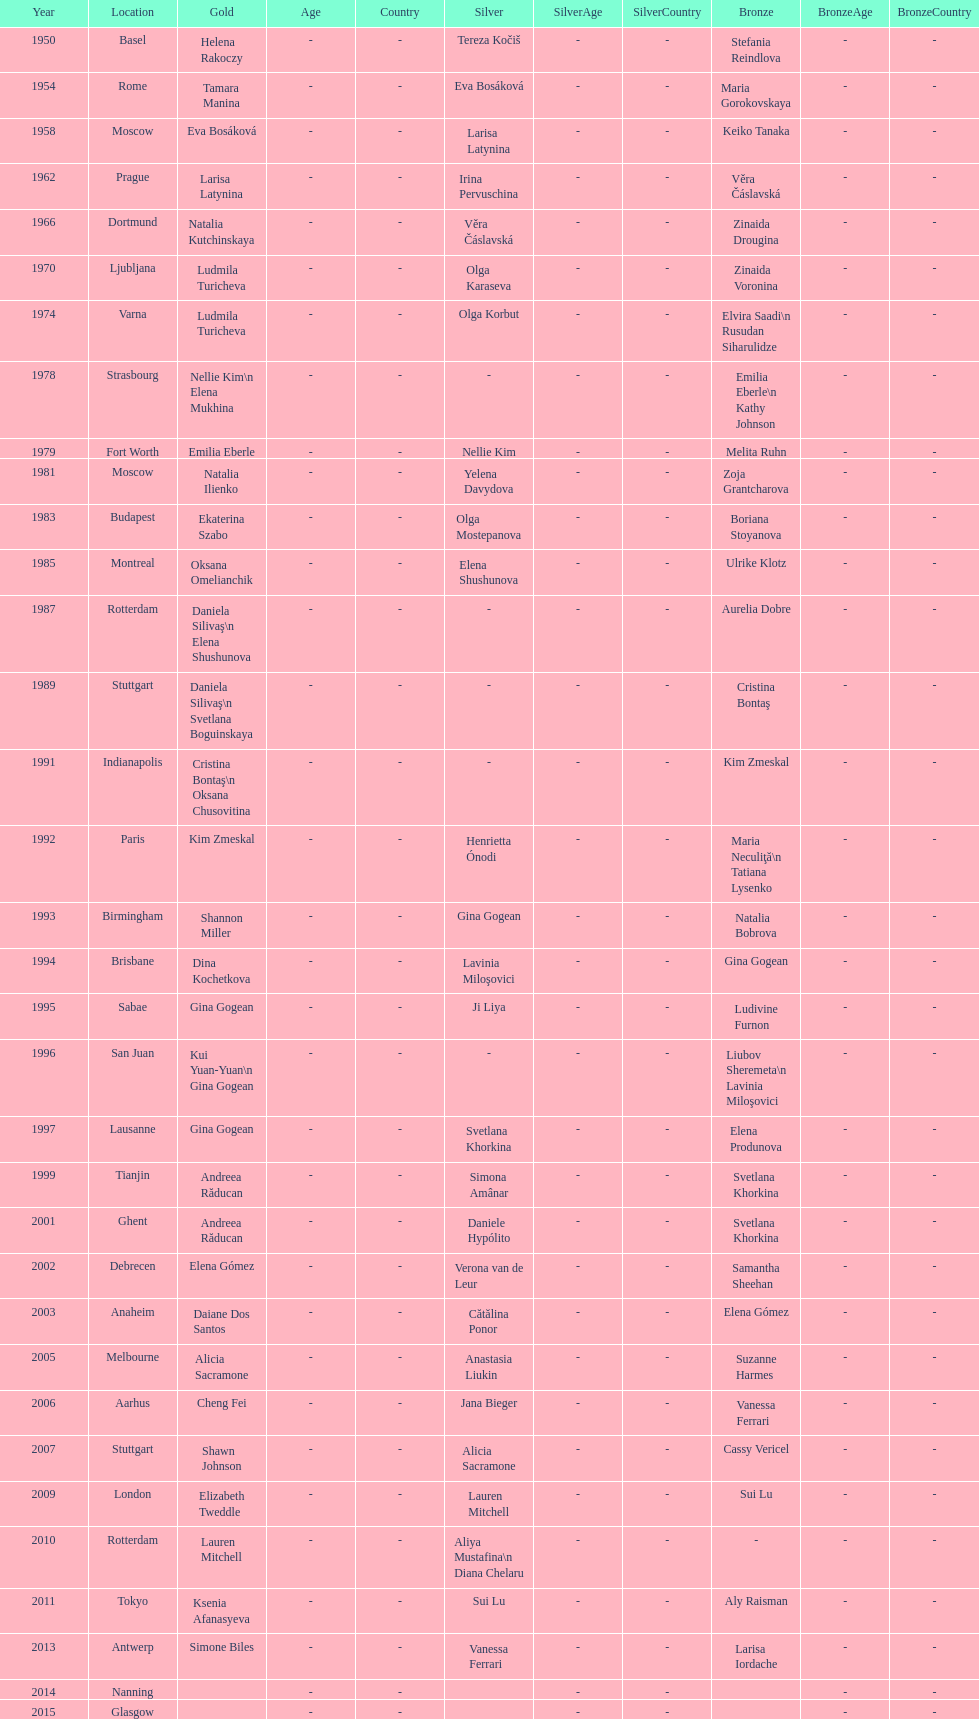As of 2013, what is the total number of floor exercise gold medals won by american women at the world championships? 5. 